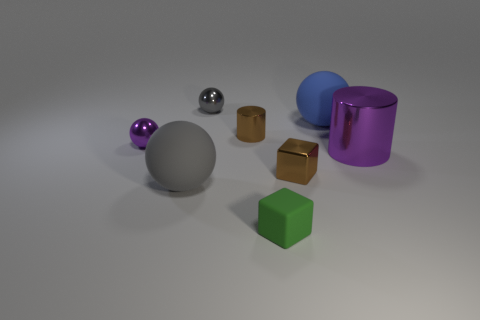Can you tell me how many objects are there in total? Certainly! In the image, there are a total of seven objects present, comprising of spheres, cubes, and cylinders in various colors and sizes. 